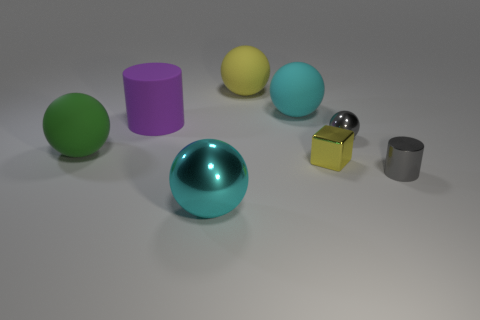Is the color of the tiny metal sphere the same as the big matte thing left of the large purple object?
Your answer should be very brief. No. What number of other things are there of the same color as the tiny shiny block?
Your response must be concise. 1. Is the number of small cyan balls less than the number of small gray spheres?
Offer a very short reply. Yes. How many tiny gray spheres are in front of the large thing behind the large cyan thing behind the small metallic cube?
Make the answer very short. 1. There is a metal ball that is to the left of the small yellow cube; what size is it?
Provide a succinct answer. Large. There is a big cyan object on the right side of the big metallic object; is it the same shape as the large purple object?
Your answer should be compact. No. There is a tiny gray thing that is the same shape as the cyan rubber object; what is it made of?
Make the answer very short. Metal. Are there any other things that are the same size as the gray sphere?
Provide a short and direct response. Yes. Is there a purple cylinder?
Offer a very short reply. Yes. What material is the ball to the left of the big cyan object that is in front of the tiny object in front of the yellow metal cube made of?
Your answer should be compact. Rubber. 